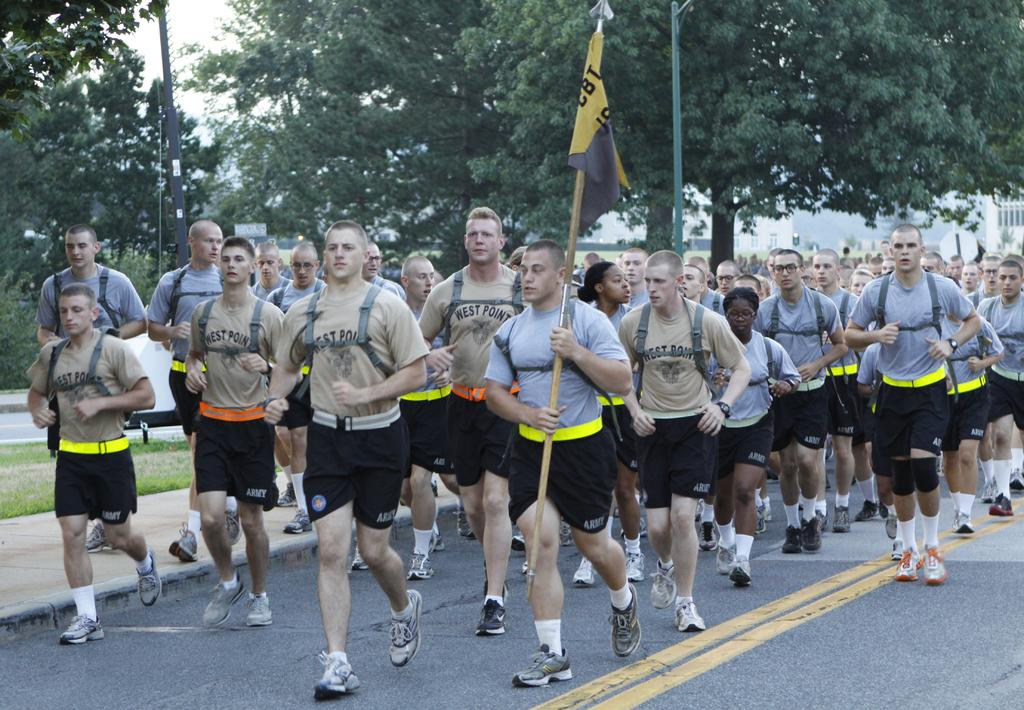What are the people in the image doing? The people in the image are jogging. Can you describe the person at the center of the group? The person at the center of the group is holding a flag. What can be seen in the background of the image? There is a building and trees in the background of the image. How many mice are running alongside the joggers in the image? There are no mice present in the image; it features a group of people jogging. What type of spy equipment can be seen in the hands of the person at the center of the group? There is no spy equipment visible in the image; the person at the center of the group is holding a flag. 